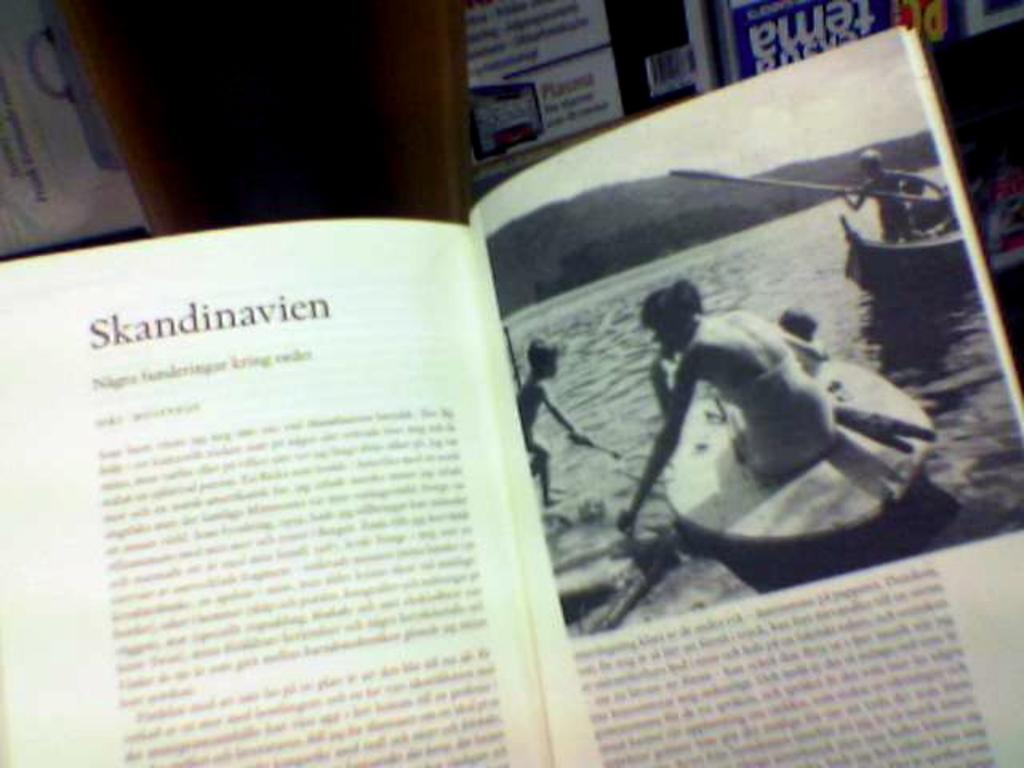Provide a one-sentence caption for the provided image. A book is open to a page titled "Skandinavien" with a picture of people in boats on the opposite page. 